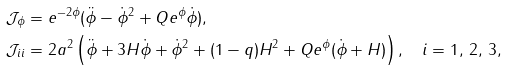<formula> <loc_0><loc_0><loc_500><loc_500>\mathcal { J } _ { \phi } & = e ^ { - 2 \phi } ( \ddot { \phi } - { \dot { \phi } } ^ { 2 } + Q e ^ { \phi } \dot { \phi } ) , \\ \mathcal { J } _ { i i } & = 2 a ^ { 2 } \left ( \ddot { \phi } + 3 H \dot { \phi } + { \dot { \phi } } ^ { 2 } + ( 1 - q ) H ^ { 2 } + Q e ^ { \phi } ( \dot { \phi } + H ) \right ) , \quad i = 1 , \, 2 , \, 3 , \\</formula> 